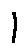Convert formula to latex. <formula><loc_0><loc_0><loc_500><loc_500>1</formula> 